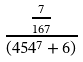Convert formula to latex. <formula><loc_0><loc_0><loc_500><loc_500>\frac { \frac { 7 } { 1 6 7 } } { ( 4 5 4 ^ { 7 } + 6 ) }</formula> 